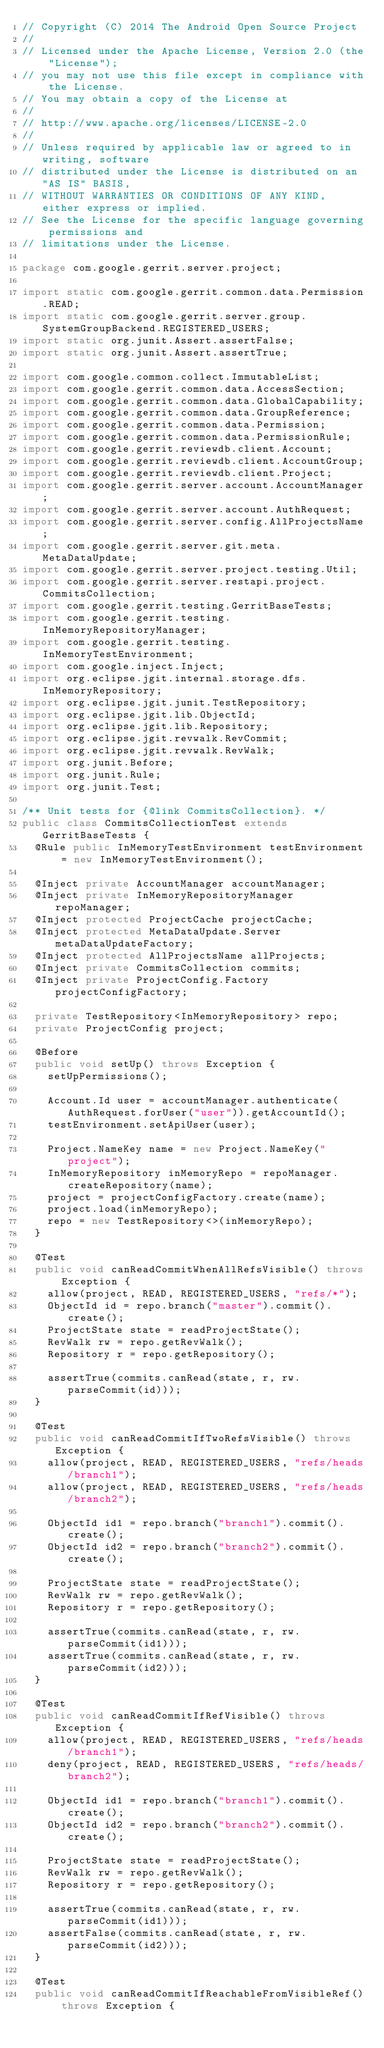<code> <loc_0><loc_0><loc_500><loc_500><_Java_>// Copyright (C) 2014 The Android Open Source Project
//
// Licensed under the Apache License, Version 2.0 (the "License");
// you may not use this file except in compliance with the License.
// You may obtain a copy of the License at
//
// http://www.apache.org/licenses/LICENSE-2.0
//
// Unless required by applicable law or agreed to in writing, software
// distributed under the License is distributed on an "AS IS" BASIS,
// WITHOUT WARRANTIES OR CONDITIONS OF ANY KIND, either express or implied.
// See the License for the specific language governing permissions and
// limitations under the License.

package com.google.gerrit.server.project;

import static com.google.gerrit.common.data.Permission.READ;
import static com.google.gerrit.server.group.SystemGroupBackend.REGISTERED_USERS;
import static org.junit.Assert.assertFalse;
import static org.junit.Assert.assertTrue;

import com.google.common.collect.ImmutableList;
import com.google.gerrit.common.data.AccessSection;
import com.google.gerrit.common.data.GlobalCapability;
import com.google.gerrit.common.data.GroupReference;
import com.google.gerrit.common.data.Permission;
import com.google.gerrit.common.data.PermissionRule;
import com.google.gerrit.reviewdb.client.Account;
import com.google.gerrit.reviewdb.client.AccountGroup;
import com.google.gerrit.reviewdb.client.Project;
import com.google.gerrit.server.account.AccountManager;
import com.google.gerrit.server.account.AuthRequest;
import com.google.gerrit.server.config.AllProjectsName;
import com.google.gerrit.server.git.meta.MetaDataUpdate;
import com.google.gerrit.server.project.testing.Util;
import com.google.gerrit.server.restapi.project.CommitsCollection;
import com.google.gerrit.testing.GerritBaseTests;
import com.google.gerrit.testing.InMemoryRepositoryManager;
import com.google.gerrit.testing.InMemoryTestEnvironment;
import com.google.inject.Inject;
import org.eclipse.jgit.internal.storage.dfs.InMemoryRepository;
import org.eclipse.jgit.junit.TestRepository;
import org.eclipse.jgit.lib.ObjectId;
import org.eclipse.jgit.lib.Repository;
import org.eclipse.jgit.revwalk.RevCommit;
import org.eclipse.jgit.revwalk.RevWalk;
import org.junit.Before;
import org.junit.Rule;
import org.junit.Test;

/** Unit tests for {@link CommitsCollection}. */
public class CommitsCollectionTest extends GerritBaseTests {
  @Rule public InMemoryTestEnvironment testEnvironment = new InMemoryTestEnvironment();

  @Inject private AccountManager accountManager;
  @Inject private InMemoryRepositoryManager repoManager;
  @Inject protected ProjectCache projectCache;
  @Inject protected MetaDataUpdate.Server metaDataUpdateFactory;
  @Inject protected AllProjectsName allProjects;
  @Inject private CommitsCollection commits;
  @Inject private ProjectConfig.Factory projectConfigFactory;

  private TestRepository<InMemoryRepository> repo;
  private ProjectConfig project;

  @Before
  public void setUp() throws Exception {
    setUpPermissions();

    Account.Id user = accountManager.authenticate(AuthRequest.forUser("user")).getAccountId();
    testEnvironment.setApiUser(user);

    Project.NameKey name = new Project.NameKey("project");
    InMemoryRepository inMemoryRepo = repoManager.createRepository(name);
    project = projectConfigFactory.create(name);
    project.load(inMemoryRepo);
    repo = new TestRepository<>(inMemoryRepo);
  }

  @Test
  public void canReadCommitWhenAllRefsVisible() throws Exception {
    allow(project, READ, REGISTERED_USERS, "refs/*");
    ObjectId id = repo.branch("master").commit().create();
    ProjectState state = readProjectState();
    RevWalk rw = repo.getRevWalk();
    Repository r = repo.getRepository();

    assertTrue(commits.canRead(state, r, rw.parseCommit(id)));
  }

  @Test
  public void canReadCommitIfTwoRefsVisible() throws Exception {
    allow(project, READ, REGISTERED_USERS, "refs/heads/branch1");
    allow(project, READ, REGISTERED_USERS, "refs/heads/branch2");

    ObjectId id1 = repo.branch("branch1").commit().create();
    ObjectId id2 = repo.branch("branch2").commit().create();

    ProjectState state = readProjectState();
    RevWalk rw = repo.getRevWalk();
    Repository r = repo.getRepository();

    assertTrue(commits.canRead(state, r, rw.parseCommit(id1)));
    assertTrue(commits.canRead(state, r, rw.parseCommit(id2)));
  }

  @Test
  public void canReadCommitIfRefVisible() throws Exception {
    allow(project, READ, REGISTERED_USERS, "refs/heads/branch1");
    deny(project, READ, REGISTERED_USERS, "refs/heads/branch2");

    ObjectId id1 = repo.branch("branch1").commit().create();
    ObjectId id2 = repo.branch("branch2").commit().create();

    ProjectState state = readProjectState();
    RevWalk rw = repo.getRevWalk();
    Repository r = repo.getRepository();

    assertTrue(commits.canRead(state, r, rw.parseCommit(id1)));
    assertFalse(commits.canRead(state, r, rw.parseCommit(id2)));
  }

  @Test
  public void canReadCommitIfReachableFromVisibleRef() throws Exception {</code> 